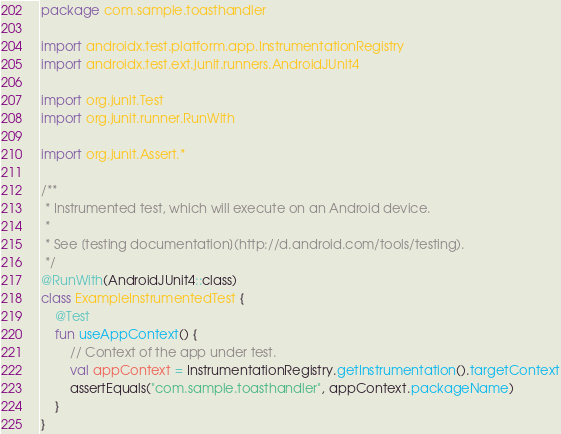Convert code to text. <code><loc_0><loc_0><loc_500><loc_500><_Kotlin_>package com.sample.toasthandler

import androidx.test.platform.app.InstrumentationRegistry
import androidx.test.ext.junit.runners.AndroidJUnit4

import org.junit.Test
import org.junit.runner.RunWith

import org.junit.Assert.*

/**
 * Instrumented test, which will execute on an Android device.
 *
 * See [testing documentation](http://d.android.com/tools/testing).
 */
@RunWith(AndroidJUnit4::class)
class ExampleInstrumentedTest {
    @Test
    fun useAppContext() {
        // Context of the app under test.
        val appContext = InstrumentationRegistry.getInstrumentation().targetContext
        assertEquals("com.sample.toasthandler", appContext.packageName)
    }
}</code> 